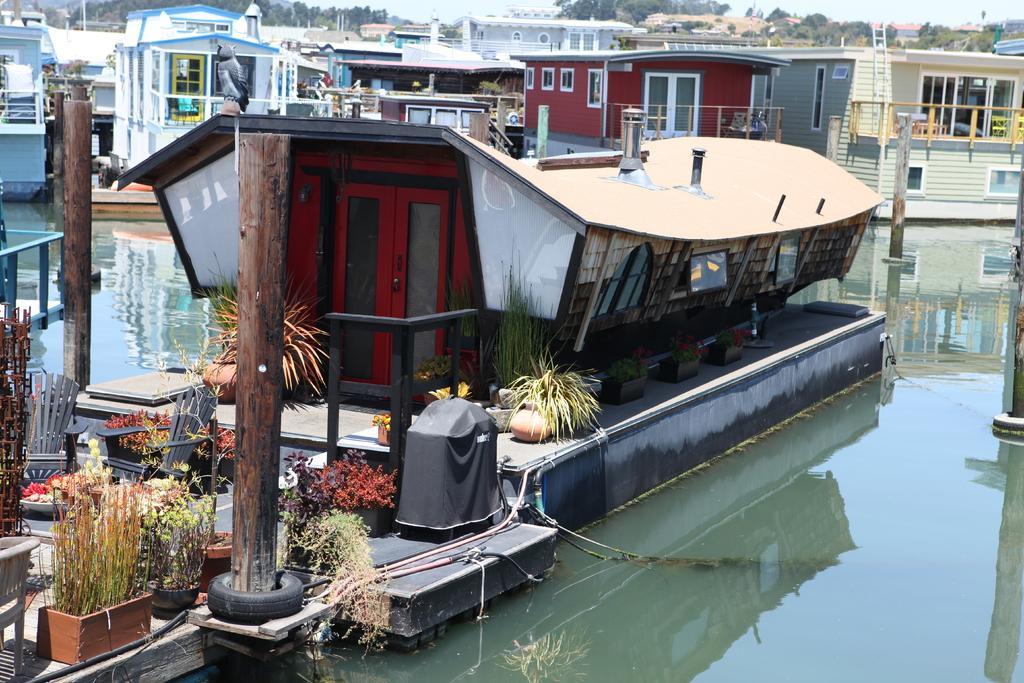How would you summarize this image in a sentence or two? In this image, there are a few houses. We can also see some trees and the sky. We can see some poles, chairs and the fence. We can see some plants. Among them, we can see some plants in pots. We can see some black colored objects. We can see some water. We can also see the reflection of houses in the water. 